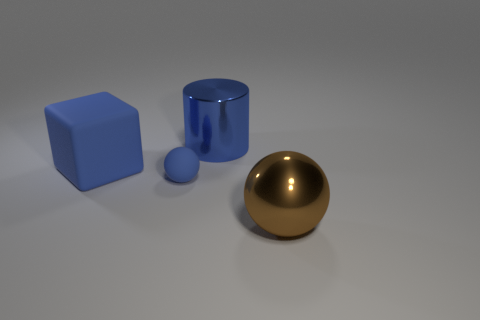How many large rubber blocks have the same color as the small sphere?
Keep it short and to the point. 1. What is the material of the big thing that is the same color as the big matte cube?
Your response must be concise. Metal. Is there anything else that is the same shape as the large blue matte object?
Provide a succinct answer. No. There is a shiny thing that is behind the large brown object; is it the same color as the rubber cube?
Give a very brief answer. Yes. Is there anything else that has the same size as the blue sphere?
Keep it short and to the point. No. How many objects are large metallic objects that are to the left of the brown metal thing or big things that are on the left side of the large blue metal cylinder?
Your answer should be compact. 2. Is the size of the cylinder the same as the metallic sphere?
Offer a very short reply. Yes. Is the number of blue rubber cubes greater than the number of metal things?
Provide a short and direct response. No. What number of other objects are the same color as the matte cube?
Give a very brief answer. 2. How many things are shiny cylinders or tiny purple metal cubes?
Provide a short and direct response. 1. 